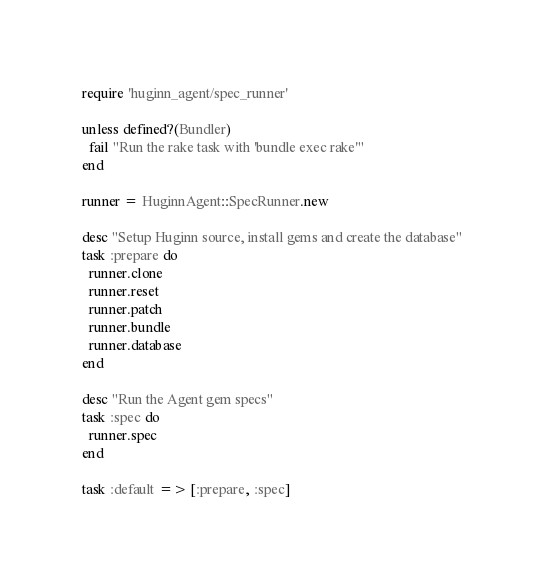<code> <loc_0><loc_0><loc_500><loc_500><_Ruby_>require 'huginn_agent/spec_runner'

unless defined?(Bundler)
  fail "Run the rake task with 'bundle exec rake'"
end

runner = HuginnAgent::SpecRunner.new

desc "Setup Huginn source, install gems and create the database"
task :prepare do
  runner.clone
  runner.reset
  runner.patch
  runner.bundle
  runner.database
end

desc "Run the Agent gem specs"
task :spec do
  runner.spec
end

task :default => [:prepare, :spec]
</code> 